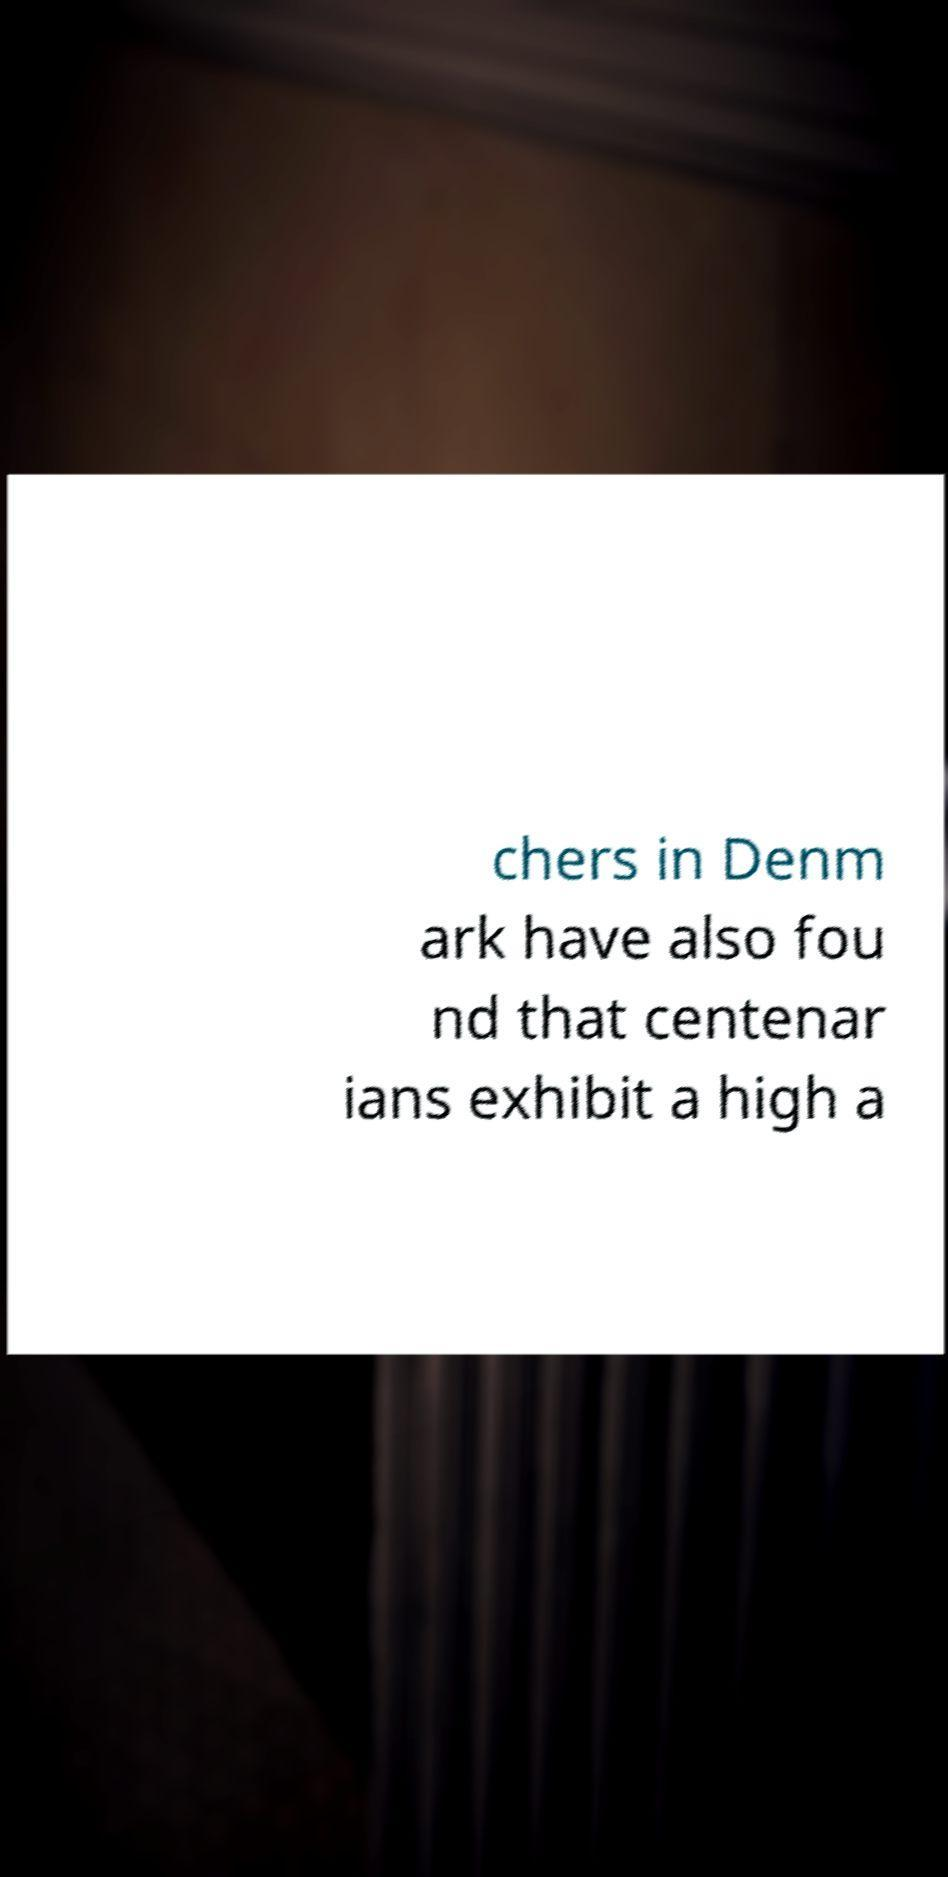Could you assist in decoding the text presented in this image and type it out clearly? chers in Denm ark have also fou nd that centenar ians exhibit a high a 